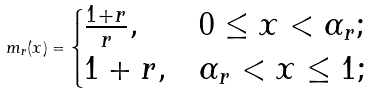<formula> <loc_0><loc_0><loc_500><loc_500>m _ { r } ( x ) = \begin{cases} \frac { 1 + r } r , & 0 \leq x < \alpha _ { r } ; \\ 1 + r , & \alpha _ { r } < x \leq 1 ; \end{cases}</formula> 